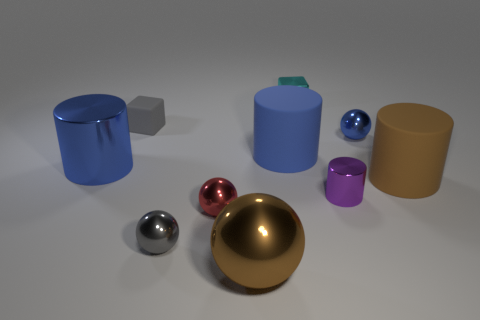Subtract all red blocks. How many blue cylinders are left? 2 Subtract all small metallic cylinders. How many cylinders are left? 3 Subtract all purple cylinders. How many cylinders are left? 3 Subtract 1 spheres. How many spheres are left? 3 Subtract all cylinders. How many objects are left? 6 Subtract all gray cylinders. Subtract all purple balls. How many cylinders are left? 4 Subtract 0 green spheres. How many objects are left? 10 Subtract all green matte cylinders. Subtract all large brown metallic objects. How many objects are left? 9 Add 7 blue balls. How many blue balls are left? 8 Add 7 small cyan matte balls. How many small cyan matte balls exist? 7 